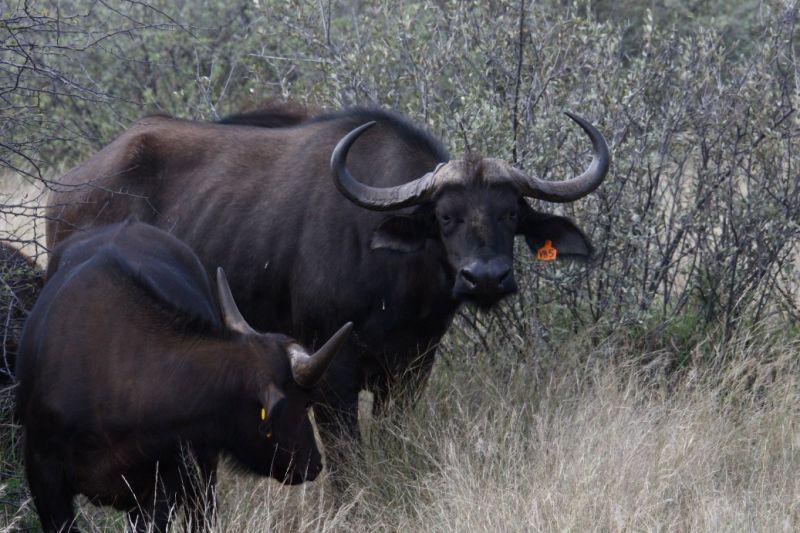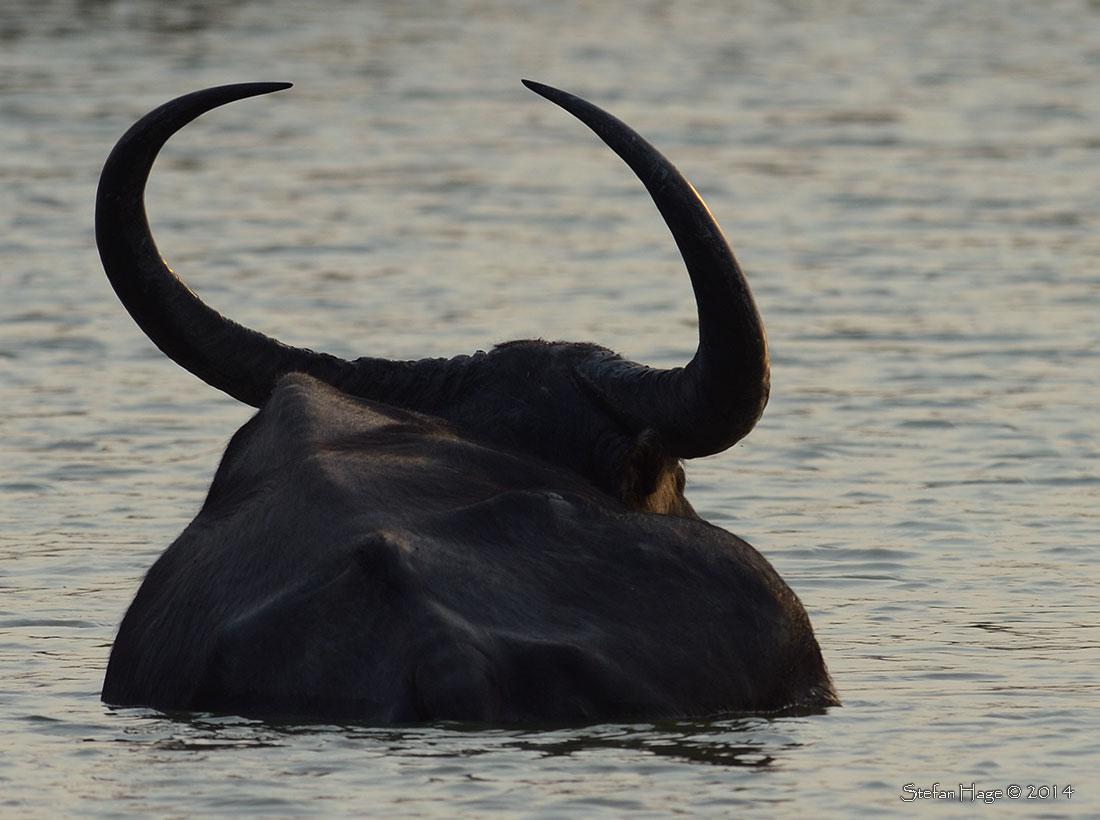The first image is the image on the left, the second image is the image on the right. Analyze the images presented: Is the assertion "There are two water buffallos wading in water." valid? Answer yes or no. No. The first image is the image on the left, the second image is the image on the right. For the images displayed, is the sentence "There is more than one animal species." factually correct? Answer yes or no. No. 